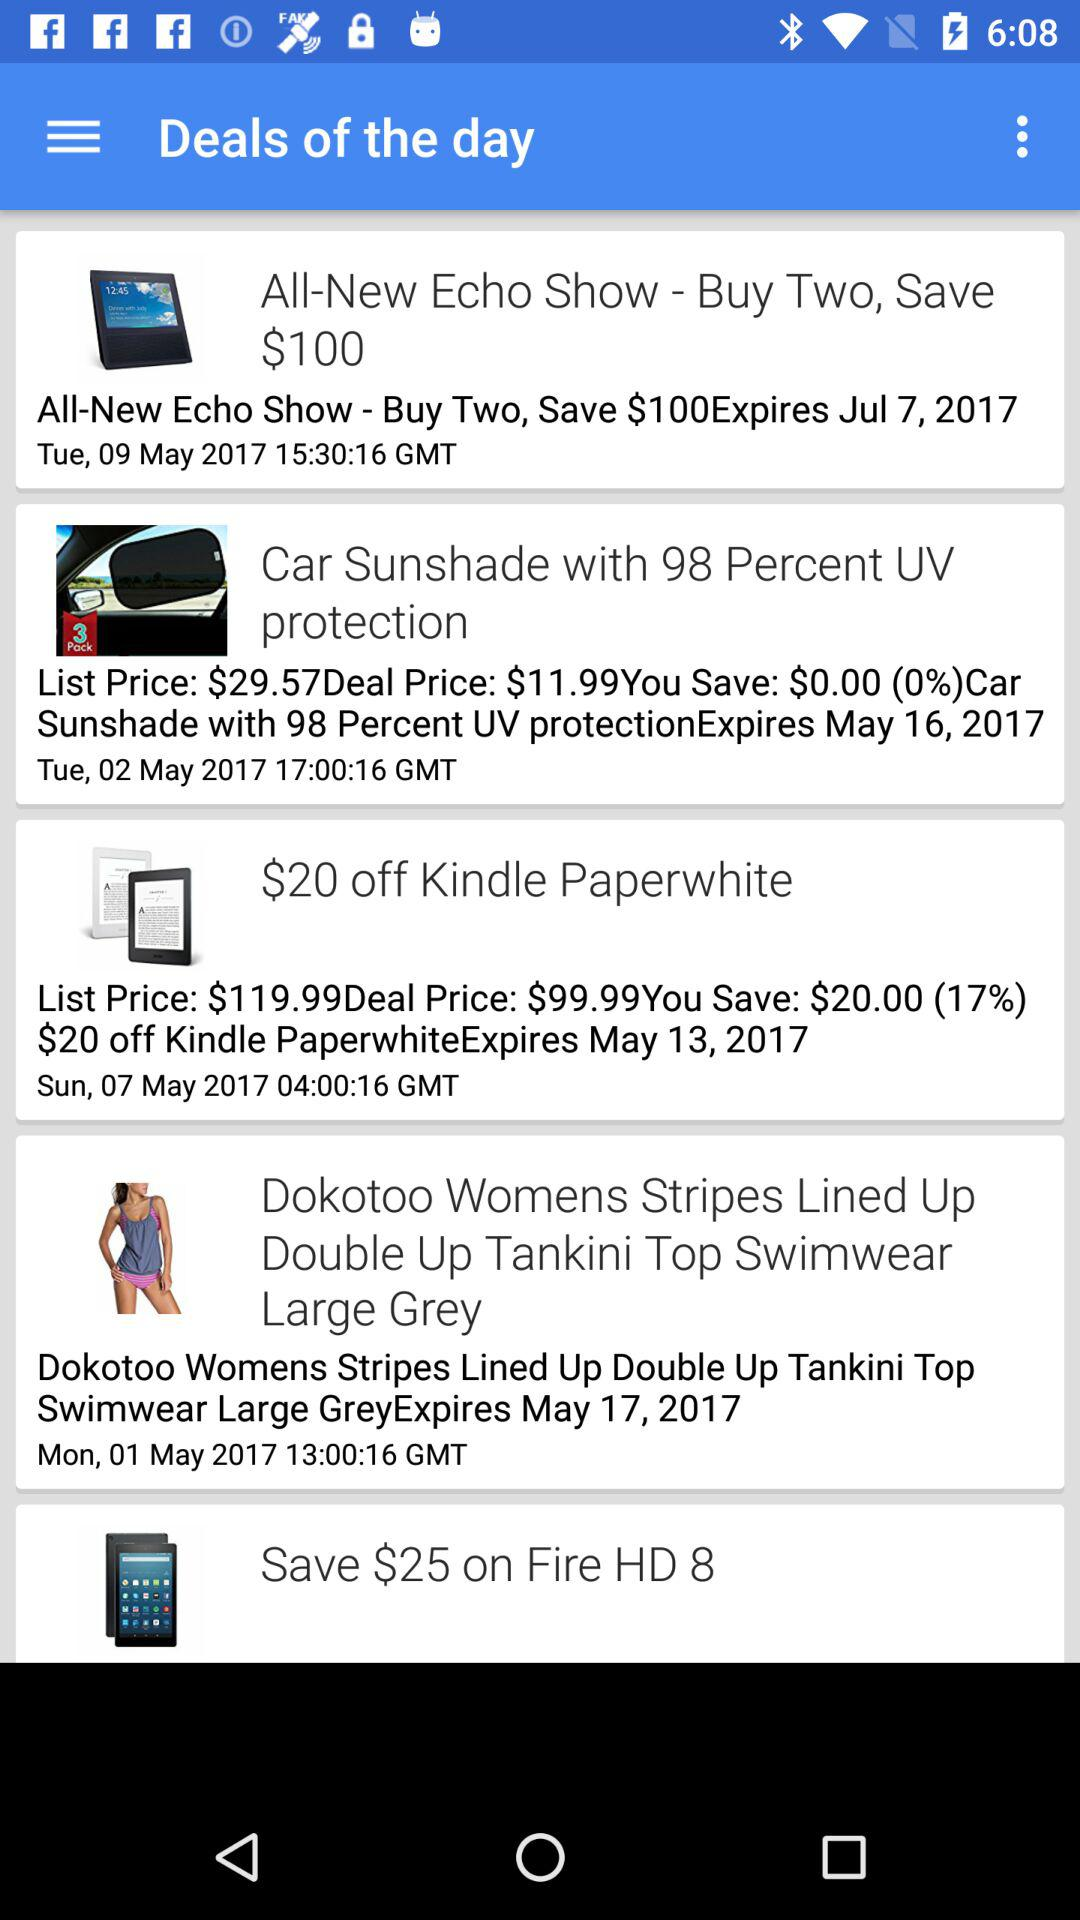Which item was marked as a favorite?
When the provided information is insufficient, respond with <no answer>. <no answer> 